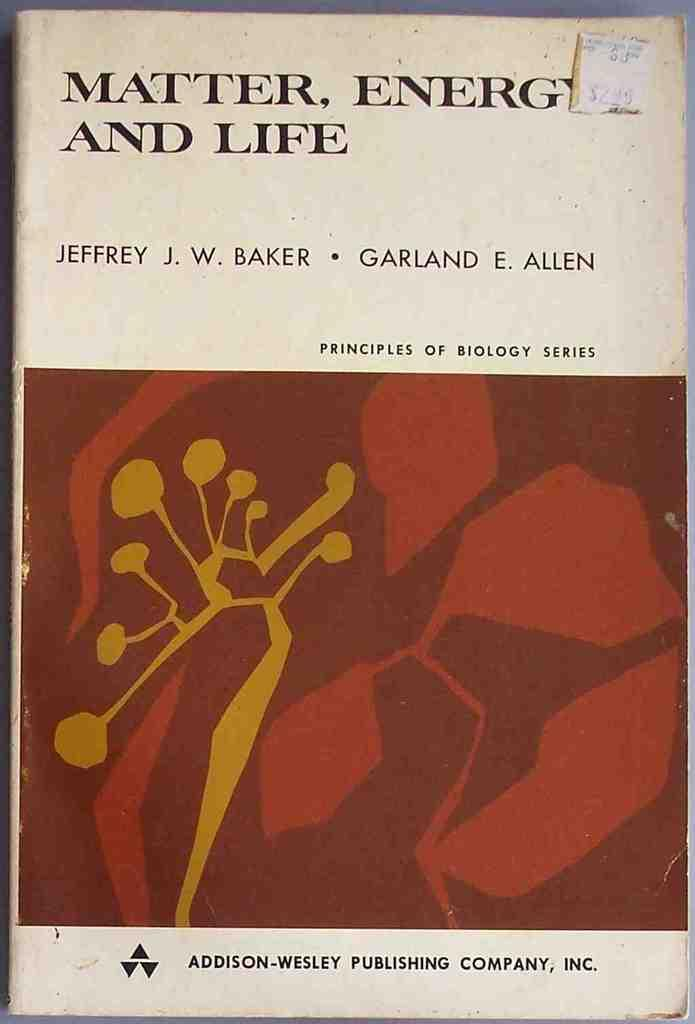<image>
Give a short and clear explanation of the subsequent image. A white book titled Matter, Energy, And Life in the principles of biology series. 